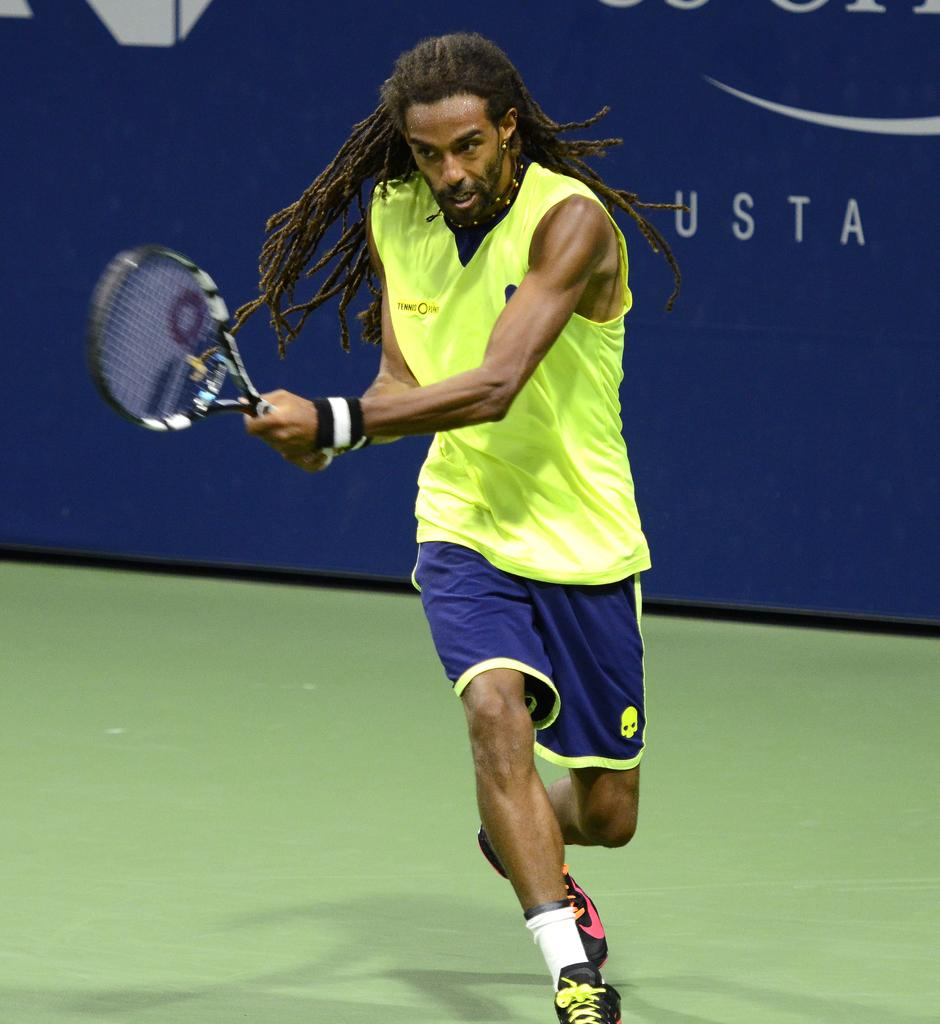Who or what is the main subject in the image? There is a person in the image. What is the person standing in front of? The person is in front of a banner. What can be observed about the person's attire? The person is wearing clothes. What object is the person holding in the image? The person is holding a tennis racket with his hands. What type of beef is being advertised on the banner in the image? There is no beef or any food item mentioned on the banner in the image; it is a tennis-related banner. 